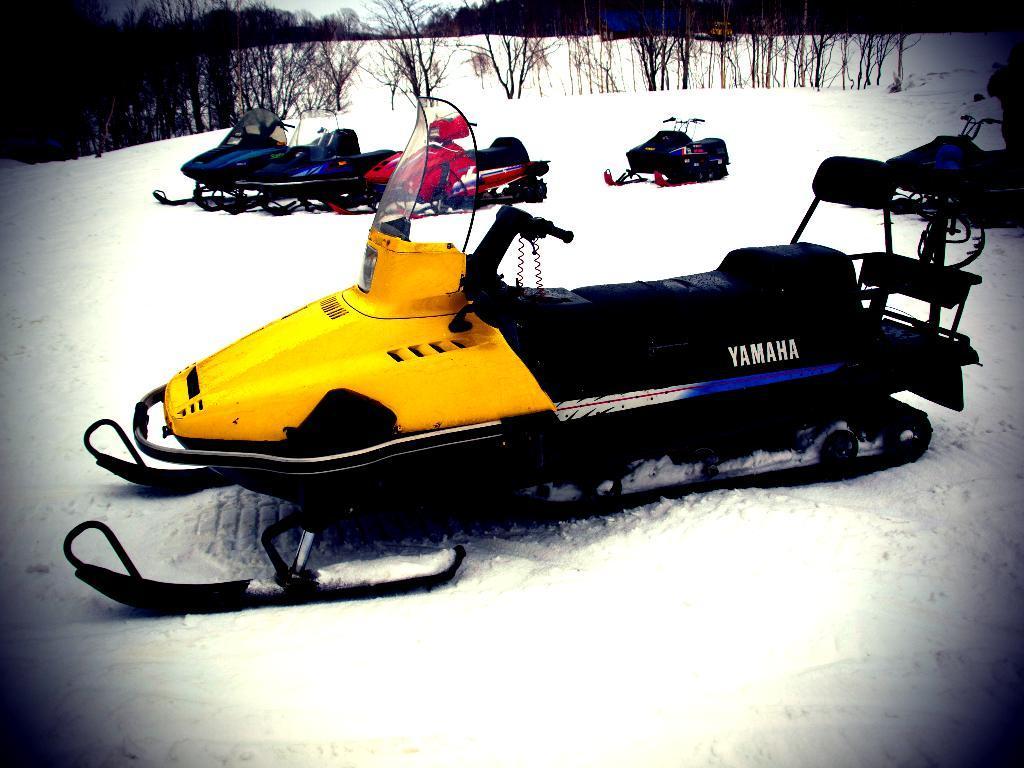Describe this image in one or two sentences. In this image I can see the snowmobiles on the snow. These are in red, yellow, black and blue color. In the background I can see many trees and the sky. 